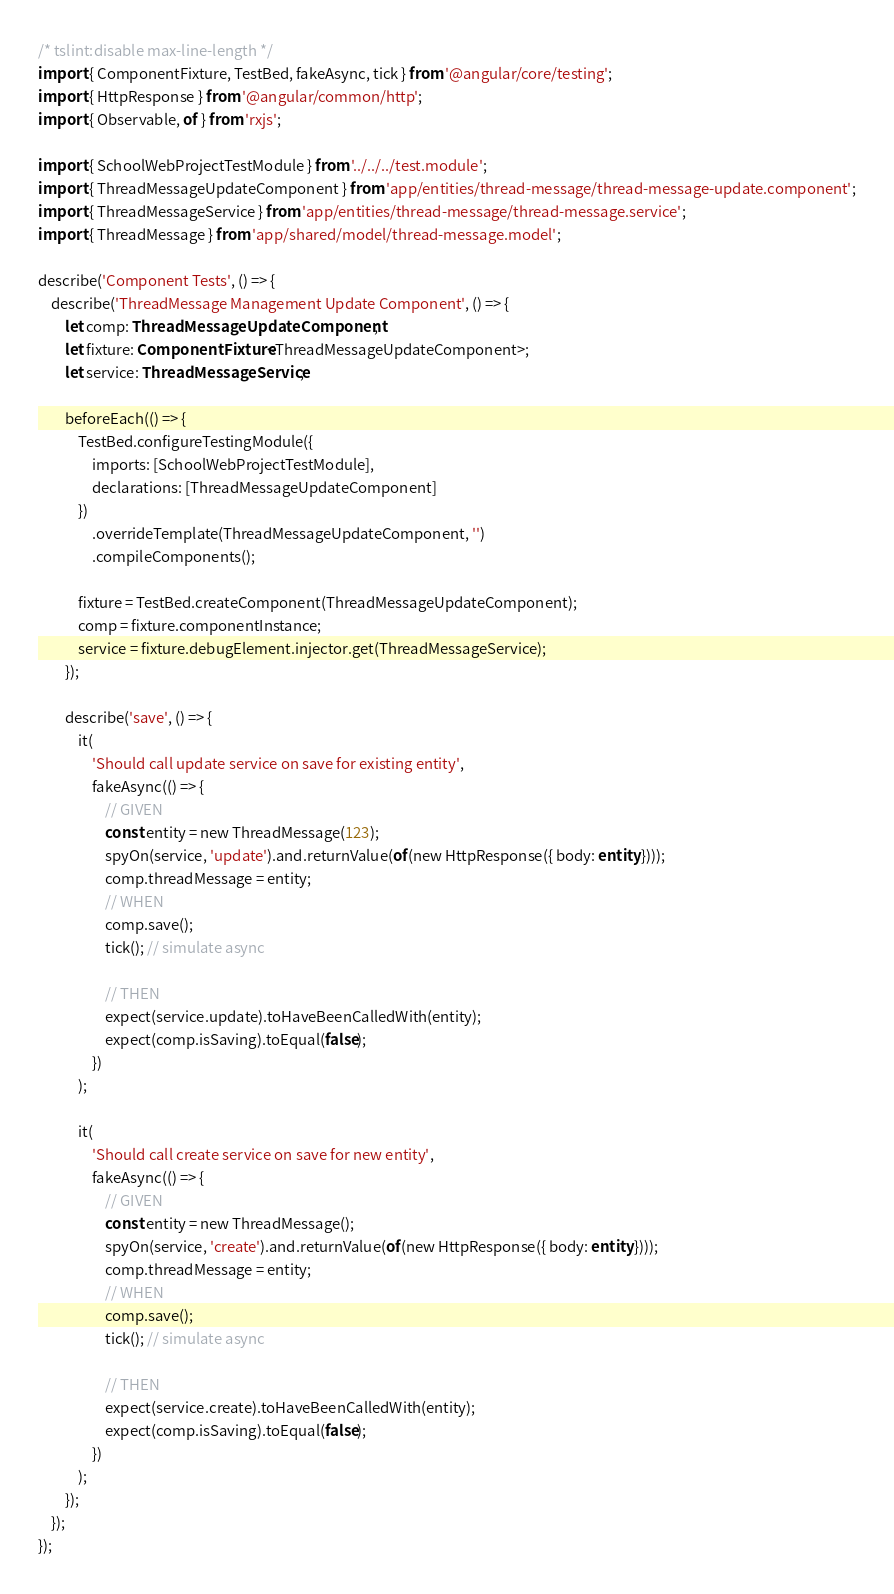<code> <loc_0><loc_0><loc_500><loc_500><_TypeScript_>/* tslint:disable max-line-length */
import { ComponentFixture, TestBed, fakeAsync, tick } from '@angular/core/testing';
import { HttpResponse } from '@angular/common/http';
import { Observable, of } from 'rxjs';

import { SchoolWebProjectTestModule } from '../../../test.module';
import { ThreadMessageUpdateComponent } from 'app/entities/thread-message/thread-message-update.component';
import { ThreadMessageService } from 'app/entities/thread-message/thread-message.service';
import { ThreadMessage } from 'app/shared/model/thread-message.model';

describe('Component Tests', () => {
    describe('ThreadMessage Management Update Component', () => {
        let comp: ThreadMessageUpdateComponent;
        let fixture: ComponentFixture<ThreadMessageUpdateComponent>;
        let service: ThreadMessageService;

        beforeEach(() => {
            TestBed.configureTestingModule({
                imports: [SchoolWebProjectTestModule],
                declarations: [ThreadMessageUpdateComponent]
            })
                .overrideTemplate(ThreadMessageUpdateComponent, '')
                .compileComponents();

            fixture = TestBed.createComponent(ThreadMessageUpdateComponent);
            comp = fixture.componentInstance;
            service = fixture.debugElement.injector.get(ThreadMessageService);
        });

        describe('save', () => {
            it(
                'Should call update service on save for existing entity',
                fakeAsync(() => {
                    // GIVEN
                    const entity = new ThreadMessage(123);
                    spyOn(service, 'update').and.returnValue(of(new HttpResponse({ body: entity })));
                    comp.threadMessage = entity;
                    // WHEN
                    comp.save();
                    tick(); // simulate async

                    // THEN
                    expect(service.update).toHaveBeenCalledWith(entity);
                    expect(comp.isSaving).toEqual(false);
                })
            );

            it(
                'Should call create service on save for new entity',
                fakeAsync(() => {
                    // GIVEN
                    const entity = new ThreadMessage();
                    spyOn(service, 'create').and.returnValue(of(new HttpResponse({ body: entity })));
                    comp.threadMessage = entity;
                    // WHEN
                    comp.save();
                    tick(); // simulate async

                    // THEN
                    expect(service.create).toHaveBeenCalledWith(entity);
                    expect(comp.isSaving).toEqual(false);
                })
            );
        });
    });
});
</code> 